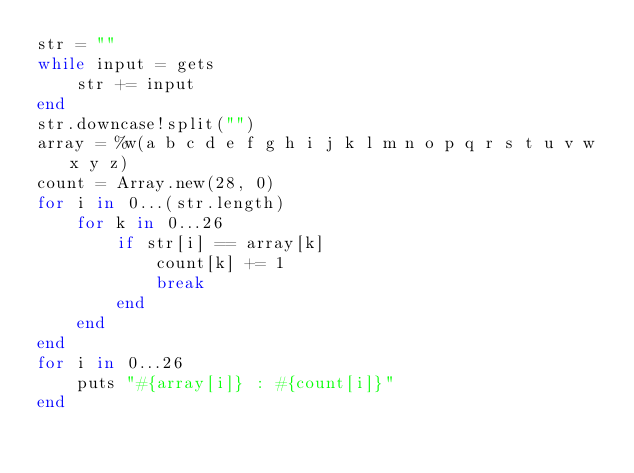Convert code to text. <code><loc_0><loc_0><loc_500><loc_500><_Ruby_>str = ""
while input = gets
	str += input
end
str.downcase!split("")
array = %w(a b c d e f g h i j k l m n o p q r s t u v w x y z)
count = Array.new(28, 0)
for i in 0...(str.length)
	for k in 0...26
		if str[i] == array[k]
			count[k] += 1
			break
		end
	end
end
for i in 0...26
	puts "#{array[i]} : #{count[i]}"
end</code> 